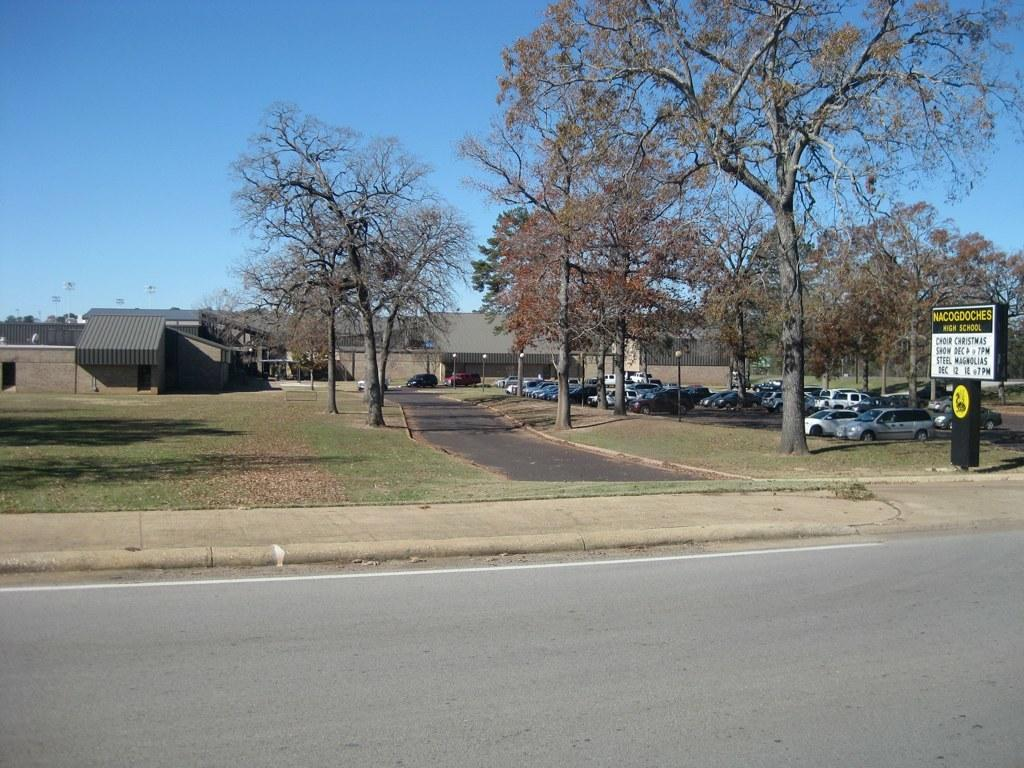What type of structures can be seen in the image? There are buildings in the image. What natural elements are present in the image? There are trees in the image. What man-made objects can be seen in the image? There are poles in the image. What type of lighting is visible in the image? Electric lights are visible in the image. What is the surface on which the motor vehicles are traveling? There is a road and pavement in the image. What type of transportation is present in the image? Motor vehicles are present on the ground in the image. What type of signage is visible in the image? Information boards are visible in the image. What part of the natural environment is visible in the image? The sky is visible in the image. Where is the flame coming from in the image? There is no flame present in the image. What type of berry is growing on the trees in the image? There are no berries mentioned or visible in the image; only trees are present. 